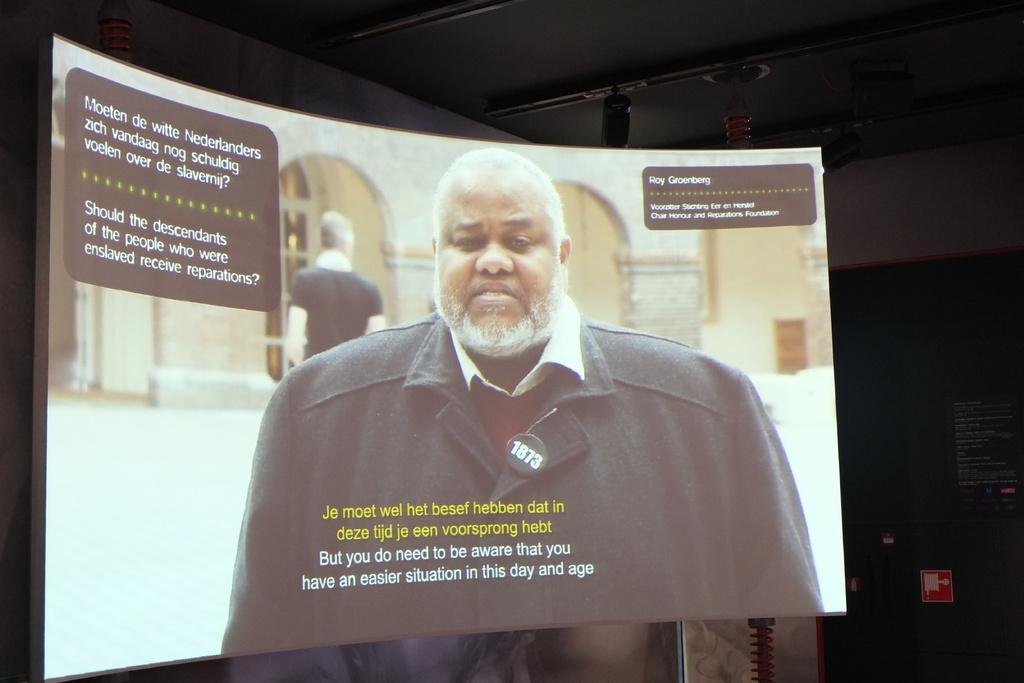Could you give a brief overview of what you see in this image? In this image we can see a screen with text and persons. In the background, we can see the board with the text and at the top we can see the objects. 